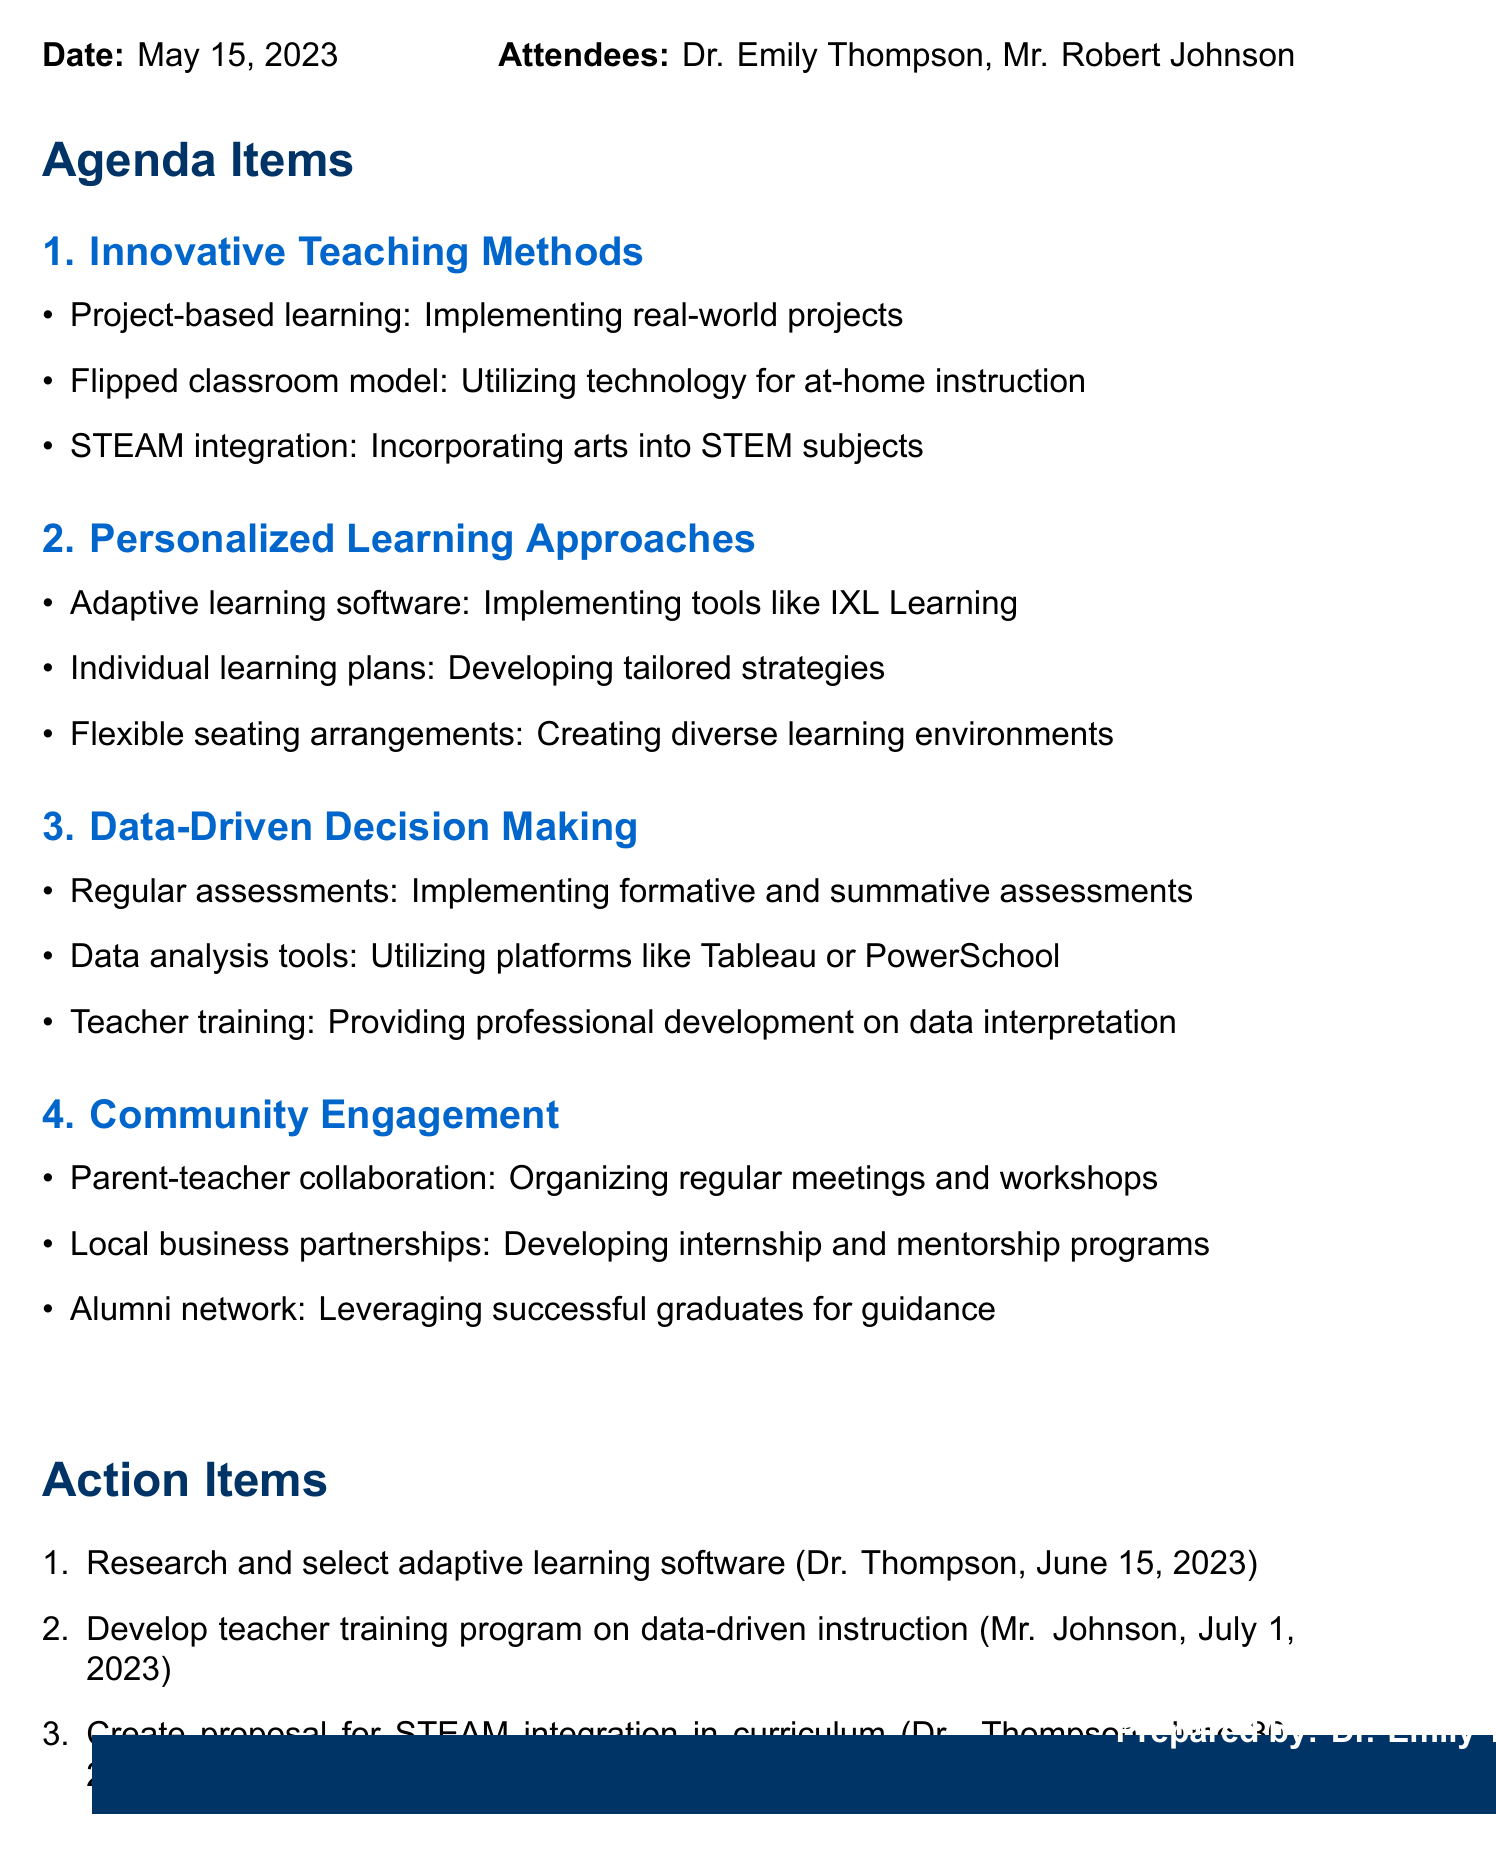What is the date of the meeting? The date of the meeting is specified in the document.
Answer: May 15, 2023 Who is the newly appointed principal? The document lists the attendees along with their roles, which includes the principal.
Answer: Dr. Emily Thompson What strategy involves implementing real-world projects? The document outlines various innovative teaching methods discussed during the meeting.
Answer: Project-based learning Which software is mentioned for adaptive learning? The discussion points list tools that can be used for personalized learning.
Answer: IXL Learning What is one action item assigned to Dr. Emily Thompson? The action items section contains tasks and their assigned individuals, including specific deadlines.
Answer: Research and select adaptive learning software What is the purpose of regular assessments according to the minutes? The document indicates that regular assessments are part of data-driven decision-making strategies.
Answer: Track progress How many discussion topics are there in the meeting minutes? By counting the sub-sections under agenda items, we can determine the number of topics discussed.
Answer: Four What is one of the reasons for parent-teacher collaboration mentioned? The community engagement section highlights efforts towards collaboration and meetings for better involvement.
Answer: Organizing regular meetings and workshops What is the deadline for creating the proposal for STEAM integration? Each action item has a specified deadline, which can be located in the action items section.
Answer: June 30, 2023 